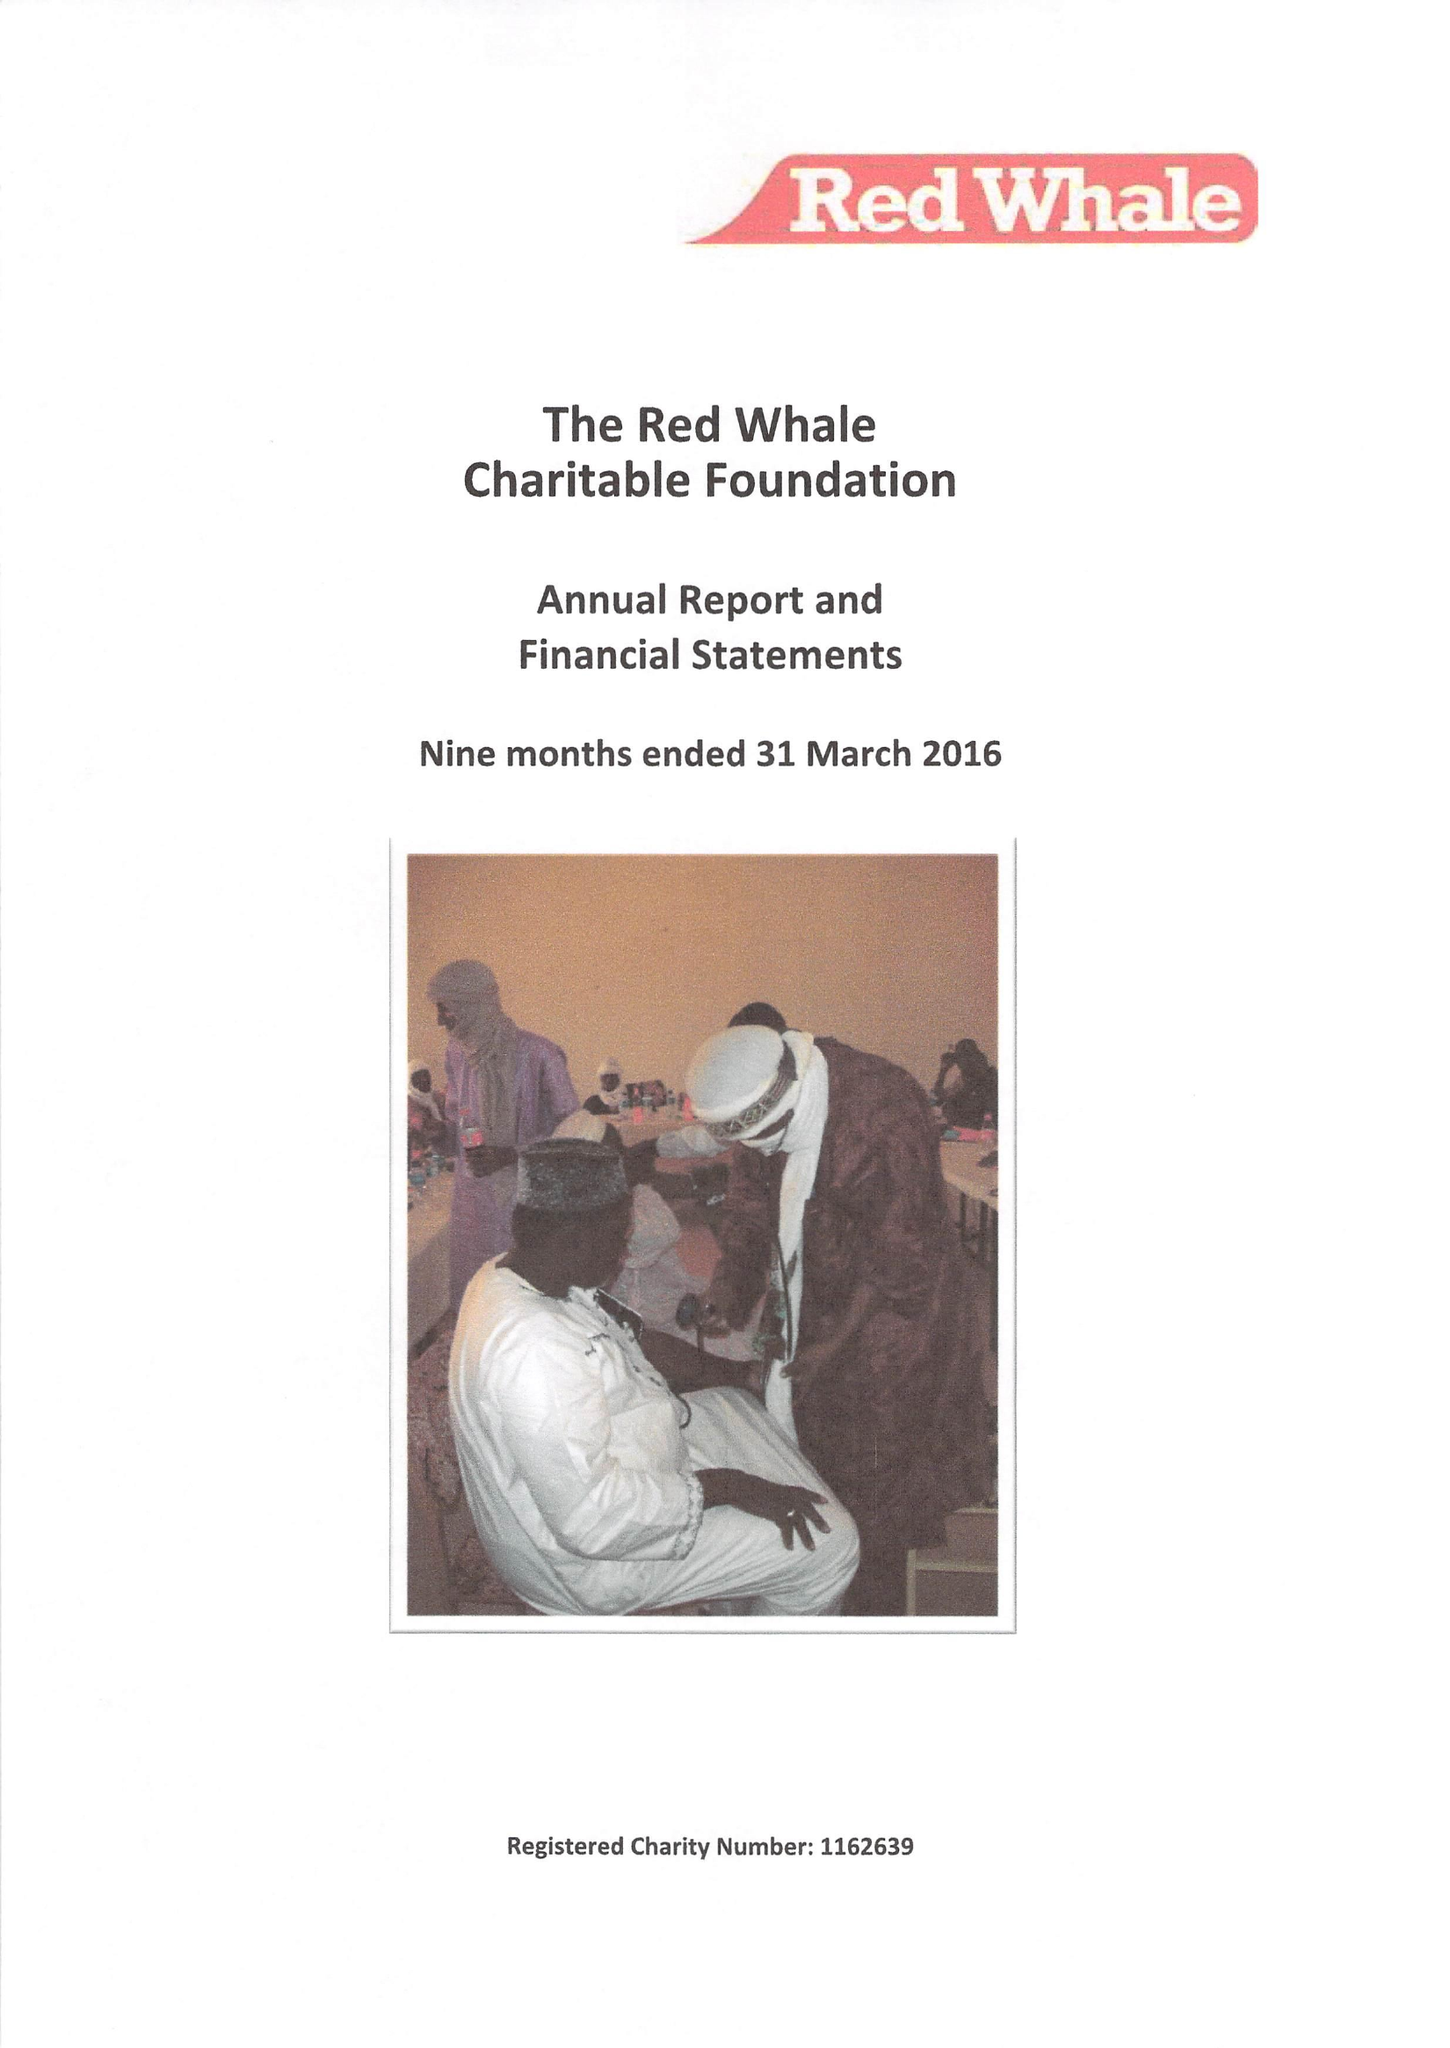What is the value for the address__street_line?
Answer the question using a single word or phrase. WHITEKNIGHTS ROAD 